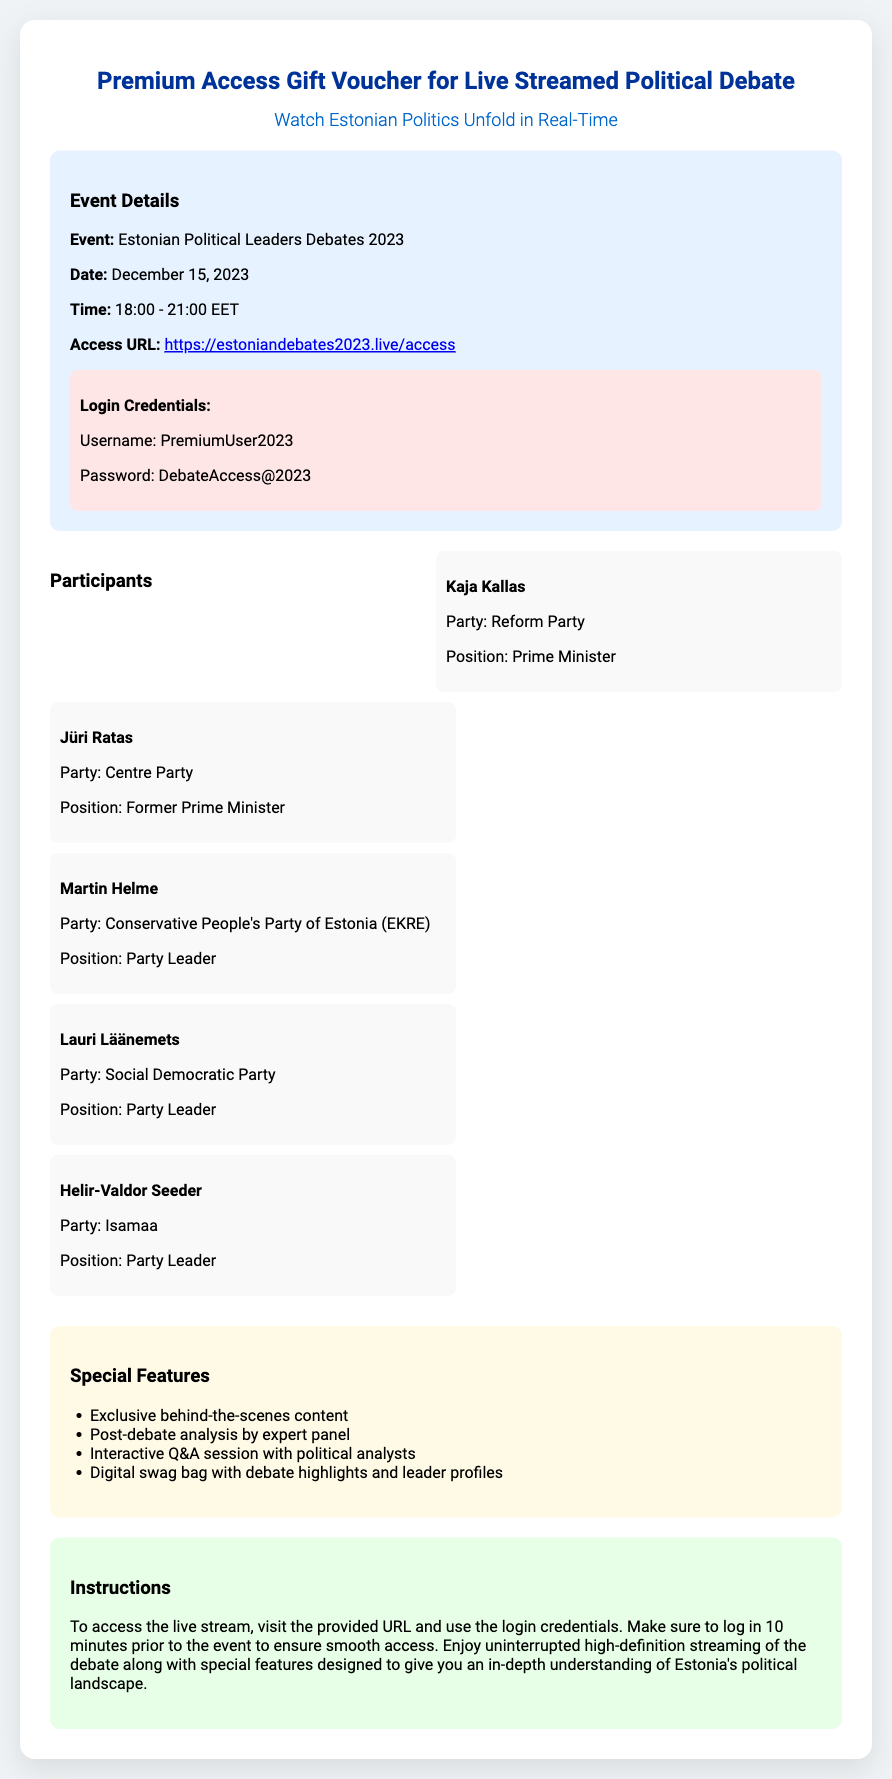What is the event date? The event date is mentioned in the document as December 15, 2023.
Answer: December 15, 2023 Who are the participants in the debate? The document lists several participants, including Kaja Kallas and Jüri Ratas.
Answer: Kaja Kallas, Jüri Ratas, Martin Helme, Lauri Läänemets, Helir-Valdor Seeder What is the event start time? The event start time is stated as 18:00 EET in the document.
Answer: 18:00 What special feature allows interaction with experts? The interactive Q&A session with political analysts is a special feature mentioned.
Answer: Interactive Q&A session What is the access URL for the event? The access URL is provided in the document as the address for the live stream.
Answer: https://estoniandebates2023.live/access What do you need to log into the event? The login credentials are specified in the document and include a username and password.
Answer: Username and Password Who is the Prime Minister mentioned in the document? The document lists Kaja Kallas as the Prime Minister among the participants.
Answer: Kaja Kallas What is the duration of the event? The document specifies that the event will last from 18:00 to 21:00 EET, indicating the total duration.
Answer: 3 hours What should attendees do before the event starts? The instructions in the document advise logging in 10 minutes prior to the event to ensure smooth access.
Answer: Log in 10 minutes prior 